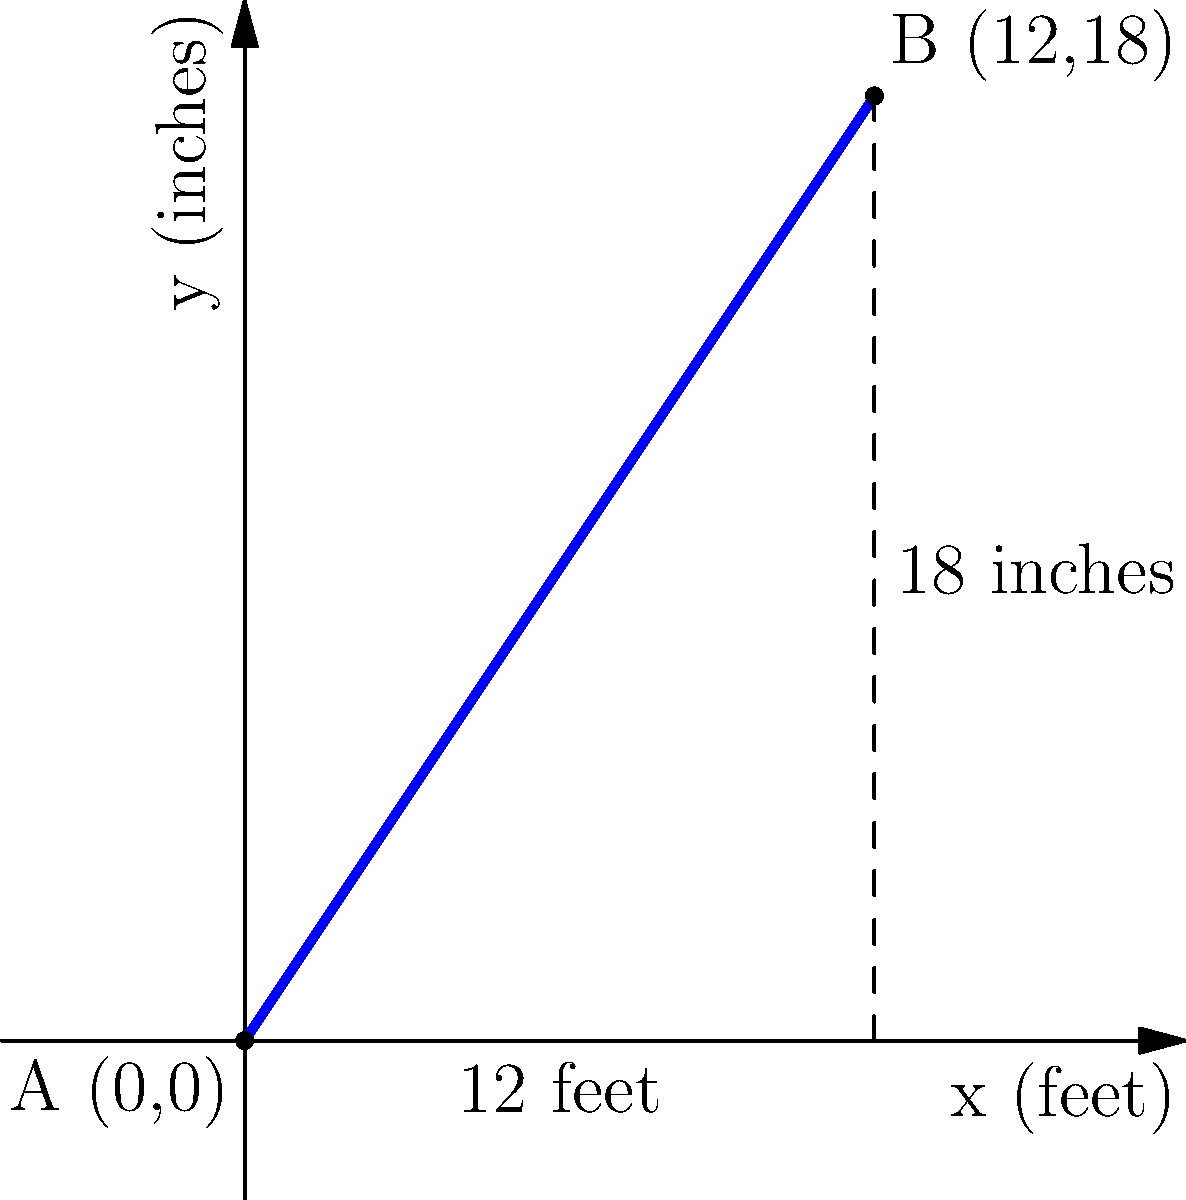A pharmacy needs to install a wheelchair ramp from the entrance to the raised pharmacy counter. The ramp starts at point A(0,0) and ends at point B(12,18), where x is measured in feet and y in inches. What is the slope of this ramp, and does it meet the ADA (Americans with Disabilities Act) requirement that the maximum slope for a wheelchair ramp should not exceed 1:12 (1 inch of rise for every 12 inches of run)? To solve this problem, we need to follow these steps:

1) Calculate the slope of the ramp:
   The slope formula is $m = \frac{\text{rise}}{\text{run}} = \frac{y_2 - y_1}{x_2 - x_1}$

   Here, $(x_1, y_1) = (0, 0)$ and $(x_2, y_2) = (12, 18)$

   $m = \frac{18 - 0}{12 - 0} = \frac{18}{12} = 1.5$

2) Convert the slope to a ratio:
   $1.5 = \frac{3}{2} = 1.5:1$

   This means for every 1 unit of horizontal distance, the ramp rises 1.5 units.

3) Convert to the ADA standard format (rise:run):
   To convert 1.5:1 to x:12, we set up the proportion:
   $\frac{1.5}{1} = \frac{x}{12}$

   Solving for x: $x = 1.5 * 12 = 18$

   So, the slope in ADA format is 18:12, which simplifies to 3:2.

4) Compare to the ADA requirement:
   The ADA requires a maximum slope of 1:12.
   Our ramp has a slope of 3:2, which is steeper than 1:12.

Therefore, this ramp does not meet the ADA requirement for wheelchair accessibility.
Answer: Slope = 1.5 or 3:2; Does not meet ADA requirement 